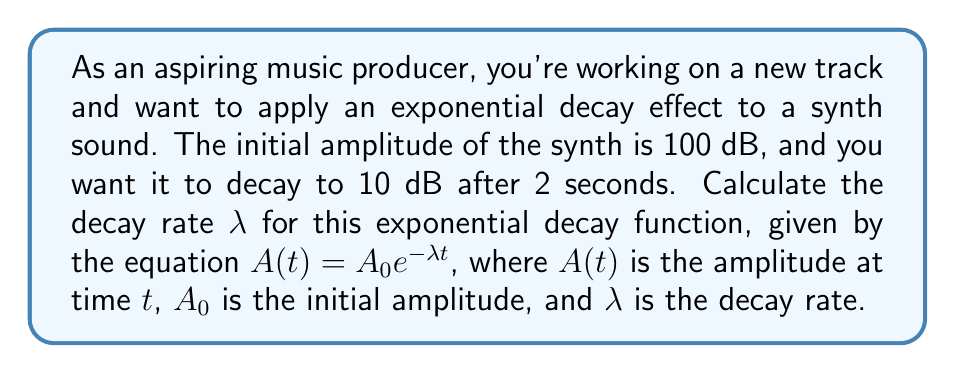Provide a solution to this math problem. Let's approach this step-by-step:

1) We're given the exponential decay function: $A(t) = A_0e^{-λt}$

2) We know:
   - Initial amplitude $A_0 = 100$ dB
   - Final amplitude $A(2) = 10$ dB
   - Time $t = 2$ seconds

3) Let's plug these values into the equation:
   $10 = 100e^{-λ(2)}$

4) Divide both sides by 100:
   $\frac{10}{100} = e^{-2λ}$
   $0.1 = e^{-2λ}$

5) Take the natural log of both sides:
   $\ln(0.1) = \ln(e^{-2λ})$
   $\ln(0.1) = -2λ$

6) Solve for λ:
   $-2λ = \ln(0.1)$
   $λ = -\frac{\ln(0.1)}{2}$

7) Calculate the value:
   $λ = -\frac{\ln(0.1)}{2} ≈ 1.15129$

Therefore, the decay rate λ is approximately 1.15129 per second.
Answer: $λ ≈ 1.15129$ s⁻¹ 